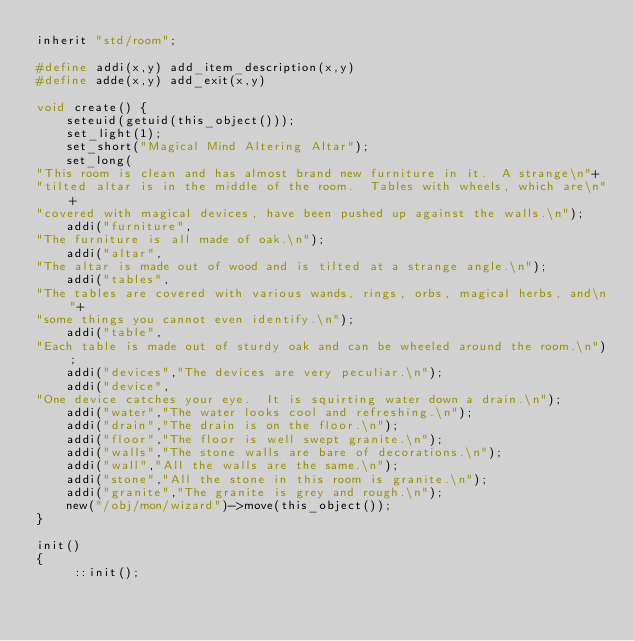<code> <loc_0><loc_0><loc_500><loc_500><_C_>inherit "std/room";
 
#define addi(x,y) add_item_description(x,y)
#define adde(x,y) add_exit(x,y)
 
void create() {
    seteuid(getuid(this_object()));
    set_light(1);
    set_short("Magical Mind Altering Altar");
    set_long(
"This room is clean and has almost brand new furniture in it.  A strange\n"+
"tilted altar is in the middle of the room.  Tables with wheels, which are\n"+
"covered with magical devices, have been pushed up against the walls.\n");
    addi("furniture",
"The furniture is all made of oak.\n");
    addi("altar",
"The altar is made out of wood and is tilted at a strange angle.\n");
    addi("tables",
"The tables are covered with various wands, rings, orbs, magical herbs, and\n"+
"some things you cannot even identify.\n");
    addi("table",
"Each table is made out of sturdy oak and can be wheeled around the room.\n");
    addi("devices","The devices are very peculiar.\n");
    addi("device",
"One device catches your eye.  It is squirting water down a drain.\n");
    addi("water","The water looks cool and refreshing.\n");
    addi("drain","The drain is on the floor.\n");
    addi("floor","The floor is well swept granite.\n");
    addi("walls","The stone walls are bare of decorations.\n");
    addi("wall","All the walls are the same.\n");
    addi("stone","All the stone in this room is granite.\n");
    addi("granite","The granite is grey and rough.\n");
    new("/obj/mon/wizard")->move(this_object());
}
 
init()
{
     ::init();</code> 